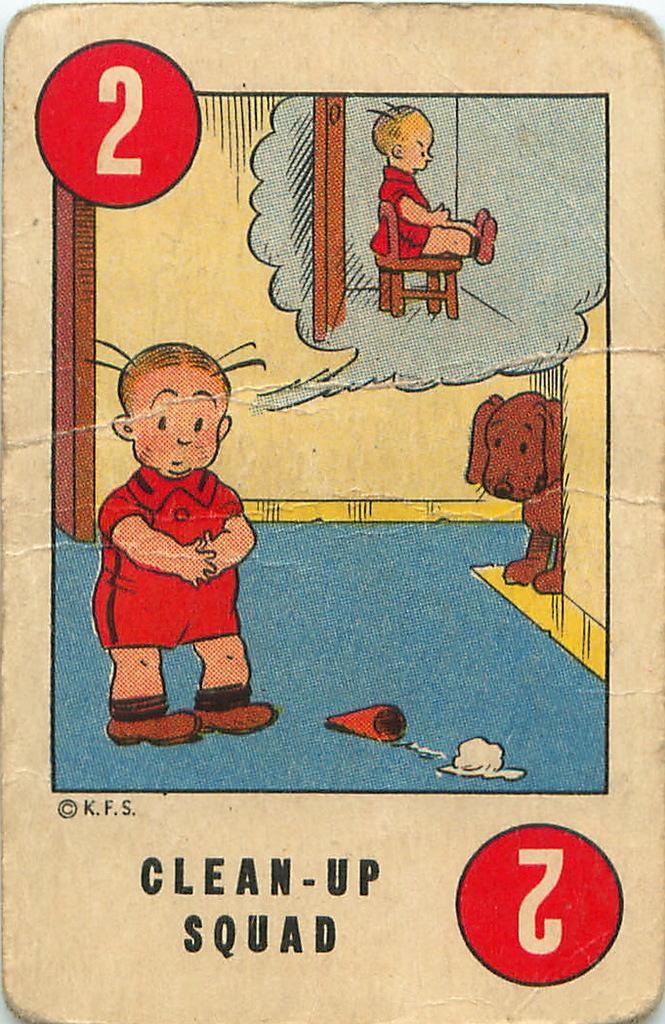Could you give a brief overview of what you see in this image? In this image I can see a poster. I can see some text on it. There is a drawing of a kid and a dog on it. 